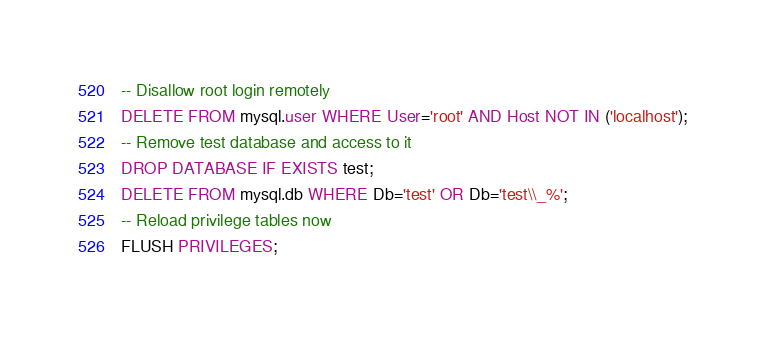<code> <loc_0><loc_0><loc_500><loc_500><_SQL_>-- Disallow root login remotely
DELETE FROM mysql.user WHERE User='root' AND Host NOT IN ('localhost');
-- Remove test database and access to it
DROP DATABASE IF EXISTS test;
DELETE FROM mysql.db WHERE Db='test' OR Db='test\\_%';
-- Reload privilege tables now
FLUSH PRIVILEGES;
</code> 